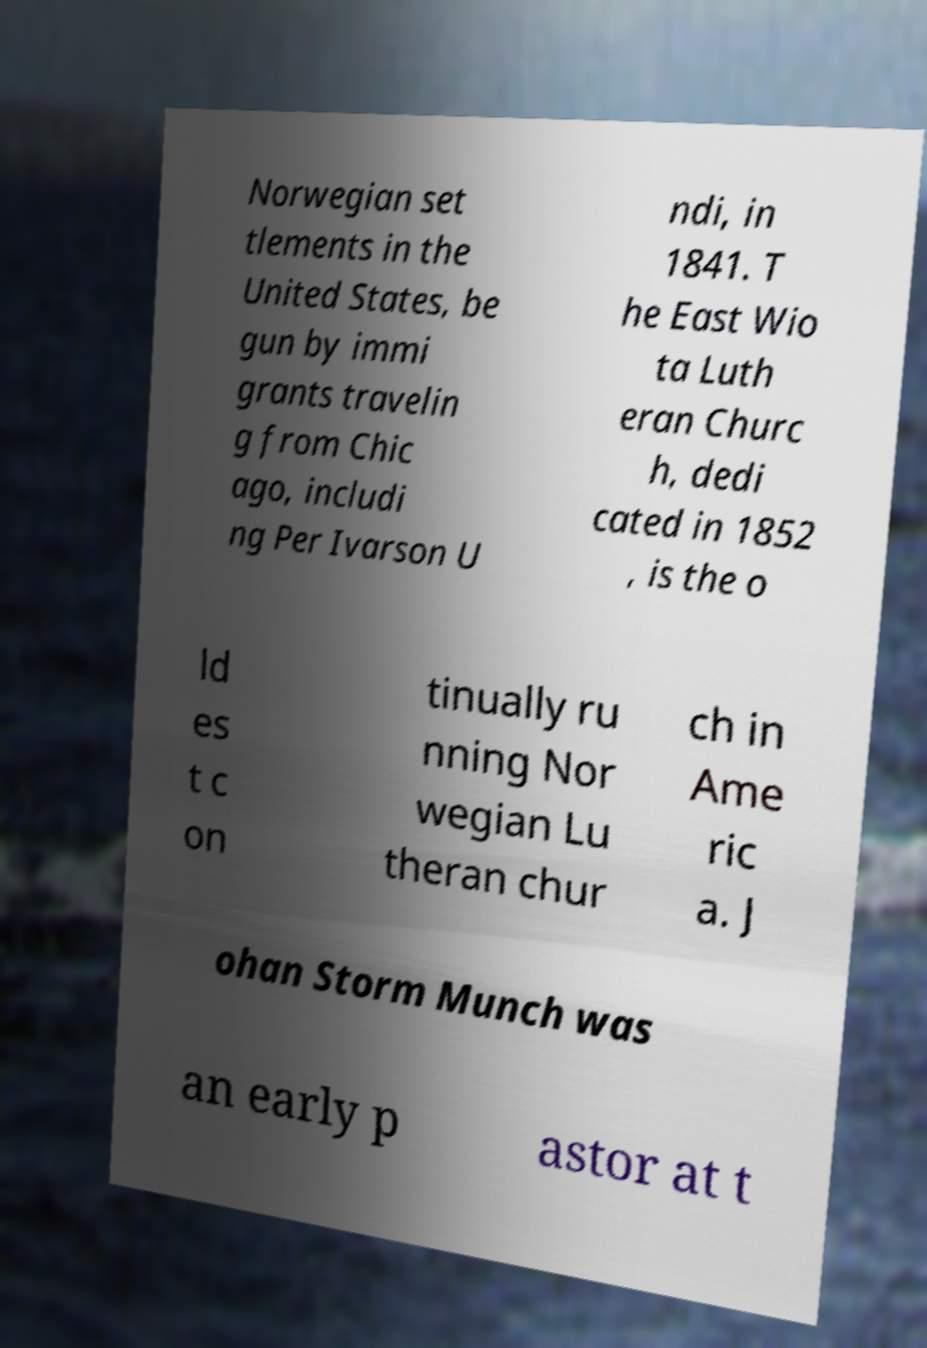Could you extract and type out the text from this image? Norwegian set tlements in the United States, be gun by immi grants travelin g from Chic ago, includi ng Per Ivarson U ndi, in 1841. T he East Wio ta Luth eran Churc h, dedi cated in 1852 , is the o ld es t c on tinually ru nning Nor wegian Lu theran chur ch in Ame ric a. J ohan Storm Munch was an early p astor at t 